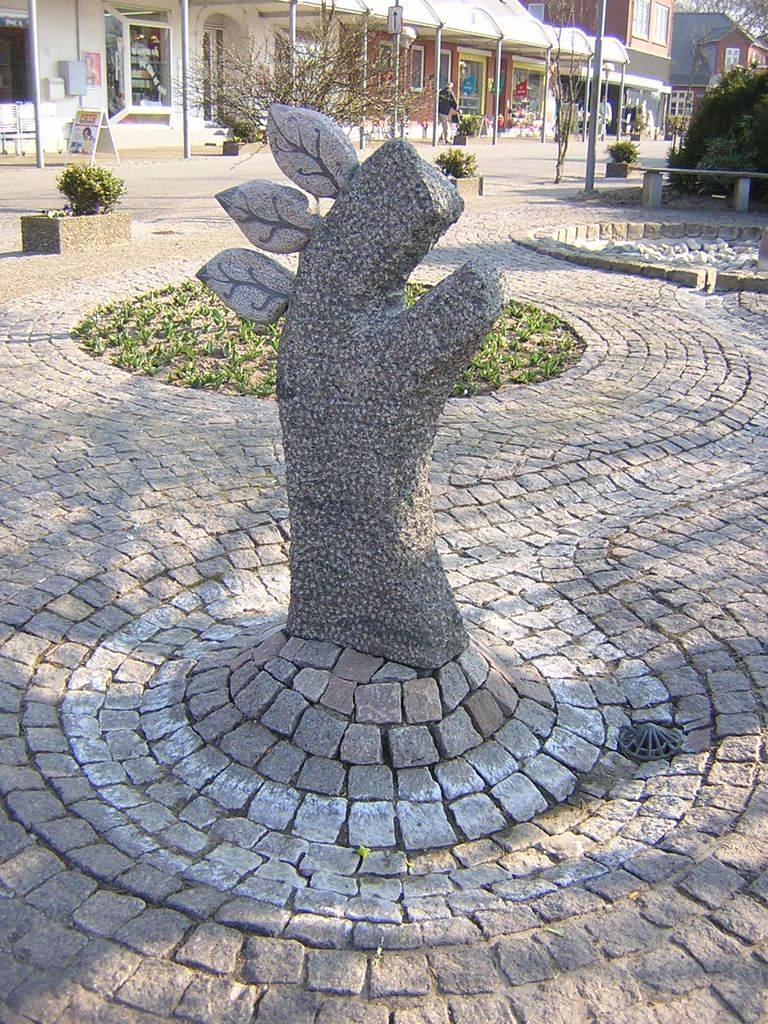Describe this image in one or two sentences. In this picture there is a statue and there are few plants,buildings and a person in the background. 